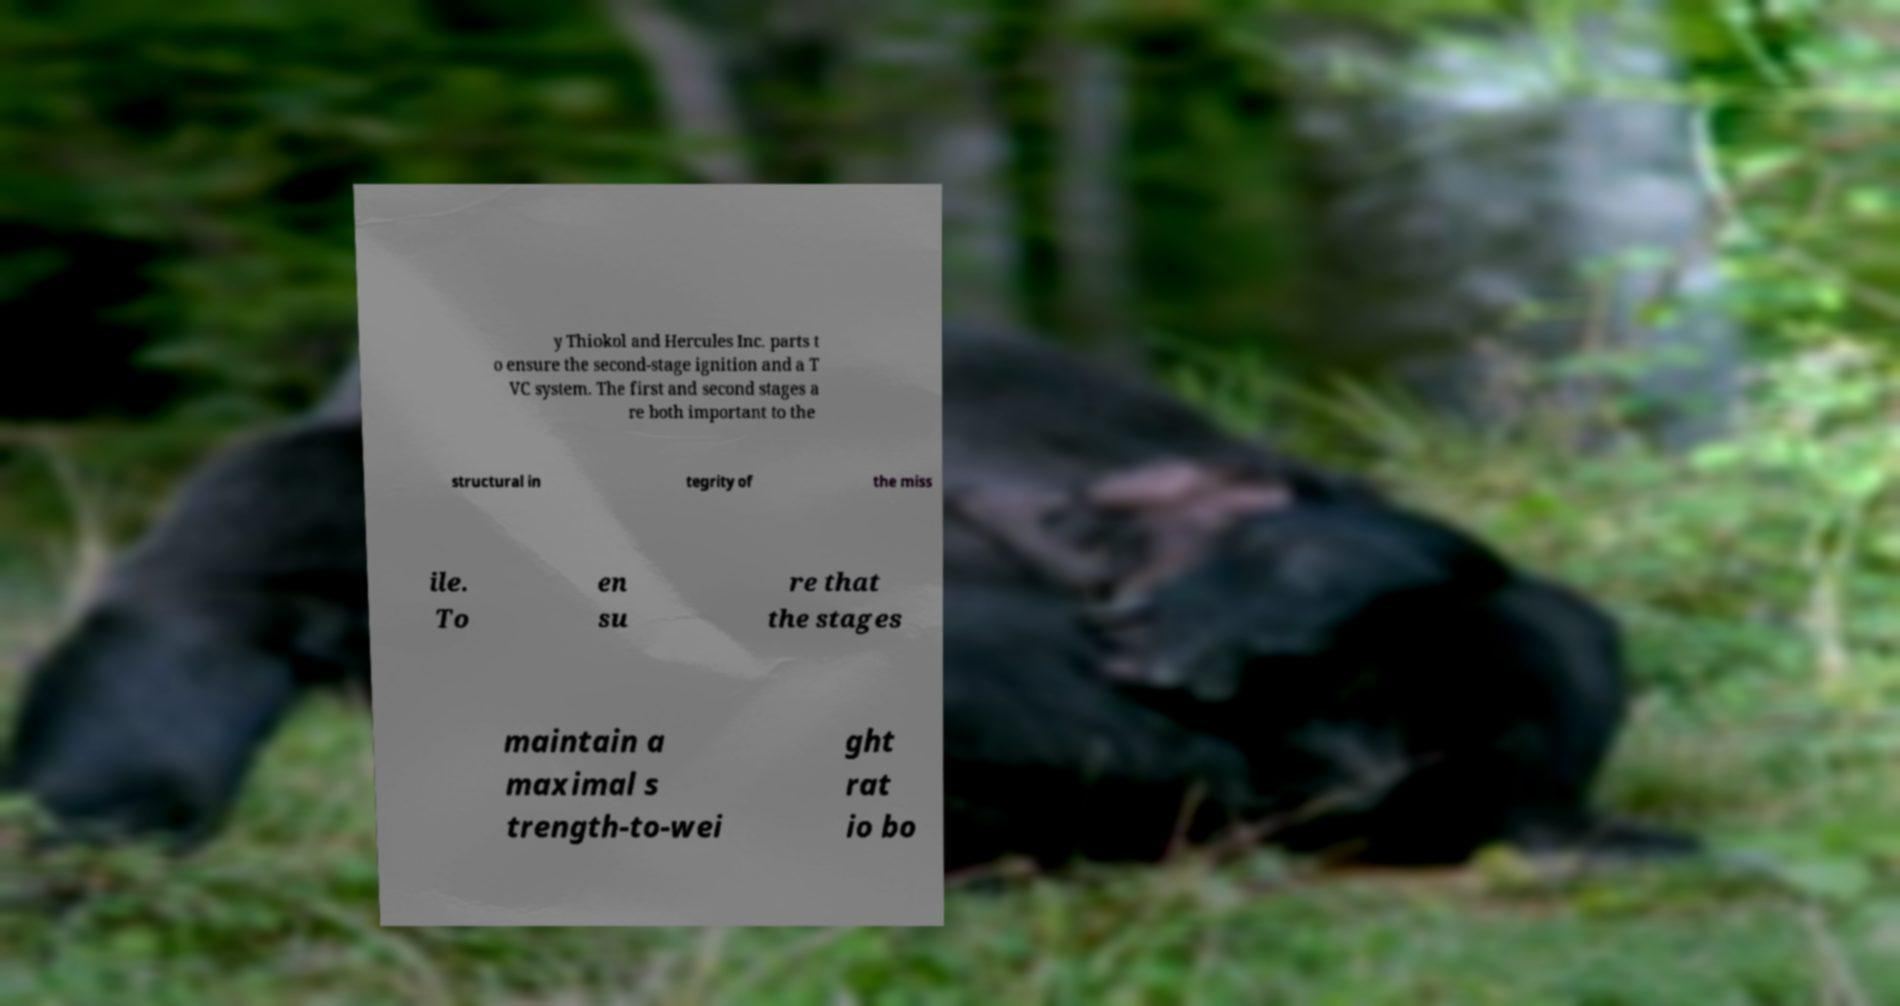Please identify and transcribe the text found in this image. y Thiokol and Hercules Inc. parts t o ensure the second-stage ignition and a T VC system. The first and second stages a re both important to the structural in tegrity of the miss ile. To en su re that the stages maintain a maximal s trength-to-wei ght rat io bo 